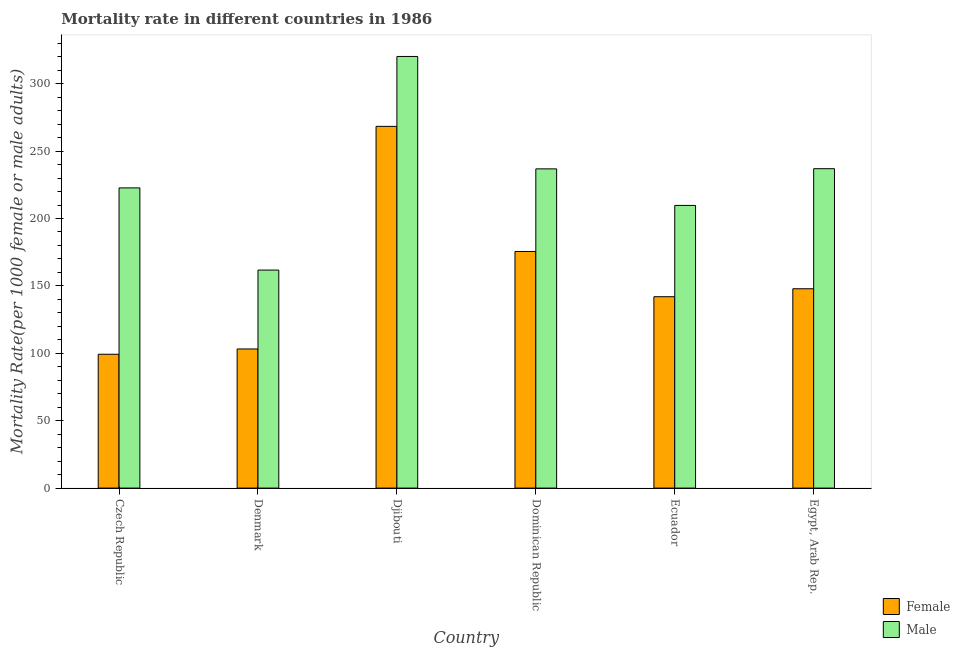How many groups of bars are there?
Your answer should be compact. 6. Are the number of bars on each tick of the X-axis equal?
Your answer should be compact. Yes. How many bars are there on the 6th tick from the left?
Give a very brief answer. 2. What is the label of the 6th group of bars from the left?
Give a very brief answer. Egypt, Arab Rep. In how many cases, is the number of bars for a given country not equal to the number of legend labels?
Offer a very short reply. 0. What is the female mortality rate in Egypt, Arab Rep.?
Keep it short and to the point. 147.88. Across all countries, what is the maximum female mortality rate?
Your response must be concise. 268.34. Across all countries, what is the minimum female mortality rate?
Your response must be concise. 99.28. In which country was the female mortality rate maximum?
Provide a short and direct response. Djibouti. In which country was the male mortality rate minimum?
Provide a short and direct response. Denmark. What is the total male mortality rate in the graph?
Your response must be concise. 1388.06. What is the difference between the male mortality rate in Dominican Republic and that in Ecuador?
Offer a terse response. 27.11. What is the difference between the male mortality rate in Ecuador and the female mortality rate in Czech Republic?
Ensure brevity in your answer.  110.41. What is the average male mortality rate per country?
Your response must be concise. 231.34. What is the difference between the male mortality rate and female mortality rate in Czech Republic?
Give a very brief answer. 123.42. What is the ratio of the female mortality rate in Czech Republic to that in Ecuador?
Give a very brief answer. 0.7. Is the female mortality rate in Denmark less than that in Egypt, Arab Rep.?
Provide a short and direct response. Yes. What is the difference between the highest and the second highest female mortality rate?
Offer a very short reply. 92.81. What is the difference between the highest and the lowest female mortality rate?
Ensure brevity in your answer.  169.06. What does the 1st bar from the left in Czech Republic represents?
Provide a succinct answer. Female. What does the 1st bar from the right in Denmark represents?
Make the answer very short. Male. Are all the bars in the graph horizontal?
Make the answer very short. No. How many countries are there in the graph?
Ensure brevity in your answer.  6. What is the difference between two consecutive major ticks on the Y-axis?
Your response must be concise. 50. Does the graph contain any zero values?
Provide a succinct answer. No. Does the graph contain grids?
Your response must be concise. No. Where does the legend appear in the graph?
Your response must be concise. Bottom right. How are the legend labels stacked?
Your answer should be compact. Vertical. What is the title of the graph?
Offer a very short reply. Mortality rate in different countries in 1986. What is the label or title of the X-axis?
Provide a short and direct response. Country. What is the label or title of the Y-axis?
Offer a terse response. Mortality Rate(per 1000 female or male adults). What is the Mortality Rate(per 1000 female or male adults) in Female in Czech Republic?
Offer a very short reply. 99.28. What is the Mortality Rate(per 1000 female or male adults) of Male in Czech Republic?
Offer a very short reply. 222.7. What is the Mortality Rate(per 1000 female or male adults) of Female in Denmark?
Your answer should be compact. 103.21. What is the Mortality Rate(per 1000 female or male adults) of Male in Denmark?
Your answer should be compact. 161.73. What is the Mortality Rate(per 1000 female or male adults) of Female in Djibouti?
Ensure brevity in your answer.  268.34. What is the Mortality Rate(per 1000 female or male adults) in Male in Djibouti?
Your answer should be compact. 320.2. What is the Mortality Rate(per 1000 female or male adults) of Female in Dominican Republic?
Provide a short and direct response. 175.53. What is the Mortality Rate(per 1000 female or male adults) in Male in Dominican Republic?
Make the answer very short. 236.81. What is the Mortality Rate(per 1000 female or male adults) of Female in Ecuador?
Provide a short and direct response. 141.97. What is the Mortality Rate(per 1000 female or male adults) in Male in Ecuador?
Your answer should be compact. 209.69. What is the Mortality Rate(per 1000 female or male adults) of Female in Egypt, Arab Rep.?
Make the answer very short. 147.88. What is the Mortality Rate(per 1000 female or male adults) in Male in Egypt, Arab Rep.?
Keep it short and to the point. 236.94. Across all countries, what is the maximum Mortality Rate(per 1000 female or male adults) of Female?
Your answer should be very brief. 268.34. Across all countries, what is the maximum Mortality Rate(per 1000 female or male adults) in Male?
Your answer should be very brief. 320.2. Across all countries, what is the minimum Mortality Rate(per 1000 female or male adults) of Female?
Ensure brevity in your answer.  99.28. Across all countries, what is the minimum Mortality Rate(per 1000 female or male adults) of Male?
Make the answer very short. 161.73. What is the total Mortality Rate(per 1000 female or male adults) of Female in the graph?
Give a very brief answer. 936.2. What is the total Mortality Rate(per 1000 female or male adults) of Male in the graph?
Your answer should be compact. 1388.06. What is the difference between the Mortality Rate(per 1000 female or male adults) in Female in Czech Republic and that in Denmark?
Provide a succinct answer. -3.93. What is the difference between the Mortality Rate(per 1000 female or male adults) of Male in Czech Republic and that in Denmark?
Offer a very short reply. 60.97. What is the difference between the Mortality Rate(per 1000 female or male adults) of Female in Czech Republic and that in Djibouti?
Give a very brief answer. -169.06. What is the difference between the Mortality Rate(per 1000 female or male adults) of Male in Czech Republic and that in Djibouti?
Ensure brevity in your answer.  -97.5. What is the difference between the Mortality Rate(per 1000 female or male adults) of Female in Czech Republic and that in Dominican Republic?
Provide a short and direct response. -76.25. What is the difference between the Mortality Rate(per 1000 female or male adults) of Male in Czech Republic and that in Dominican Republic?
Your answer should be compact. -14.11. What is the difference between the Mortality Rate(per 1000 female or male adults) in Female in Czech Republic and that in Ecuador?
Provide a succinct answer. -42.69. What is the difference between the Mortality Rate(per 1000 female or male adults) of Male in Czech Republic and that in Ecuador?
Offer a very short reply. 13.01. What is the difference between the Mortality Rate(per 1000 female or male adults) in Female in Czech Republic and that in Egypt, Arab Rep.?
Your response must be concise. -48.59. What is the difference between the Mortality Rate(per 1000 female or male adults) of Male in Czech Republic and that in Egypt, Arab Rep.?
Keep it short and to the point. -14.24. What is the difference between the Mortality Rate(per 1000 female or male adults) in Female in Denmark and that in Djibouti?
Give a very brief answer. -165.13. What is the difference between the Mortality Rate(per 1000 female or male adults) in Male in Denmark and that in Djibouti?
Provide a short and direct response. -158.47. What is the difference between the Mortality Rate(per 1000 female or male adults) in Female in Denmark and that in Dominican Republic?
Give a very brief answer. -72.32. What is the difference between the Mortality Rate(per 1000 female or male adults) in Male in Denmark and that in Dominican Republic?
Your response must be concise. -75.08. What is the difference between the Mortality Rate(per 1000 female or male adults) of Female in Denmark and that in Ecuador?
Your response must be concise. -38.76. What is the difference between the Mortality Rate(per 1000 female or male adults) in Male in Denmark and that in Ecuador?
Your answer should be compact. -47.96. What is the difference between the Mortality Rate(per 1000 female or male adults) of Female in Denmark and that in Egypt, Arab Rep.?
Make the answer very short. -44.67. What is the difference between the Mortality Rate(per 1000 female or male adults) of Male in Denmark and that in Egypt, Arab Rep.?
Make the answer very short. -75.21. What is the difference between the Mortality Rate(per 1000 female or male adults) in Female in Djibouti and that in Dominican Republic?
Ensure brevity in your answer.  92.81. What is the difference between the Mortality Rate(per 1000 female or male adults) in Male in Djibouti and that in Dominican Republic?
Offer a terse response. 83.39. What is the difference between the Mortality Rate(per 1000 female or male adults) of Female in Djibouti and that in Ecuador?
Ensure brevity in your answer.  126.37. What is the difference between the Mortality Rate(per 1000 female or male adults) of Male in Djibouti and that in Ecuador?
Your response must be concise. 110.51. What is the difference between the Mortality Rate(per 1000 female or male adults) in Female in Djibouti and that in Egypt, Arab Rep.?
Provide a succinct answer. 120.46. What is the difference between the Mortality Rate(per 1000 female or male adults) of Male in Djibouti and that in Egypt, Arab Rep.?
Provide a succinct answer. 83.27. What is the difference between the Mortality Rate(per 1000 female or male adults) of Female in Dominican Republic and that in Ecuador?
Give a very brief answer. 33.56. What is the difference between the Mortality Rate(per 1000 female or male adults) of Male in Dominican Republic and that in Ecuador?
Ensure brevity in your answer.  27.11. What is the difference between the Mortality Rate(per 1000 female or male adults) of Female in Dominican Republic and that in Egypt, Arab Rep.?
Make the answer very short. 27.66. What is the difference between the Mortality Rate(per 1000 female or male adults) of Male in Dominican Republic and that in Egypt, Arab Rep.?
Offer a terse response. -0.13. What is the difference between the Mortality Rate(per 1000 female or male adults) in Female in Ecuador and that in Egypt, Arab Rep.?
Provide a succinct answer. -5.91. What is the difference between the Mortality Rate(per 1000 female or male adults) in Male in Ecuador and that in Egypt, Arab Rep.?
Offer a very short reply. -27.24. What is the difference between the Mortality Rate(per 1000 female or male adults) of Female in Czech Republic and the Mortality Rate(per 1000 female or male adults) of Male in Denmark?
Give a very brief answer. -62.45. What is the difference between the Mortality Rate(per 1000 female or male adults) of Female in Czech Republic and the Mortality Rate(per 1000 female or male adults) of Male in Djibouti?
Your response must be concise. -220.92. What is the difference between the Mortality Rate(per 1000 female or male adults) in Female in Czech Republic and the Mortality Rate(per 1000 female or male adults) in Male in Dominican Republic?
Your answer should be very brief. -137.53. What is the difference between the Mortality Rate(per 1000 female or male adults) in Female in Czech Republic and the Mortality Rate(per 1000 female or male adults) in Male in Ecuador?
Offer a terse response. -110.41. What is the difference between the Mortality Rate(per 1000 female or male adults) in Female in Czech Republic and the Mortality Rate(per 1000 female or male adults) in Male in Egypt, Arab Rep.?
Give a very brief answer. -137.66. What is the difference between the Mortality Rate(per 1000 female or male adults) in Female in Denmark and the Mortality Rate(per 1000 female or male adults) in Male in Djibouti?
Offer a terse response. -216.99. What is the difference between the Mortality Rate(per 1000 female or male adults) in Female in Denmark and the Mortality Rate(per 1000 female or male adults) in Male in Dominican Republic?
Provide a short and direct response. -133.6. What is the difference between the Mortality Rate(per 1000 female or male adults) in Female in Denmark and the Mortality Rate(per 1000 female or male adults) in Male in Ecuador?
Offer a terse response. -106.48. What is the difference between the Mortality Rate(per 1000 female or male adults) of Female in Denmark and the Mortality Rate(per 1000 female or male adults) of Male in Egypt, Arab Rep.?
Your answer should be very brief. -133.73. What is the difference between the Mortality Rate(per 1000 female or male adults) in Female in Djibouti and the Mortality Rate(per 1000 female or male adults) in Male in Dominican Republic?
Keep it short and to the point. 31.53. What is the difference between the Mortality Rate(per 1000 female or male adults) in Female in Djibouti and the Mortality Rate(per 1000 female or male adults) in Male in Ecuador?
Give a very brief answer. 58.65. What is the difference between the Mortality Rate(per 1000 female or male adults) in Female in Djibouti and the Mortality Rate(per 1000 female or male adults) in Male in Egypt, Arab Rep.?
Make the answer very short. 31.4. What is the difference between the Mortality Rate(per 1000 female or male adults) in Female in Dominican Republic and the Mortality Rate(per 1000 female or male adults) in Male in Ecuador?
Your answer should be compact. -34.16. What is the difference between the Mortality Rate(per 1000 female or male adults) in Female in Dominican Republic and the Mortality Rate(per 1000 female or male adults) in Male in Egypt, Arab Rep.?
Make the answer very short. -61.41. What is the difference between the Mortality Rate(per 1000 female or male adults) in Female in Ecuador and the Mortality Rate(per 1000 female or male adults) in Male in Egypt, Arab Rep.?
Offer a terse response. -94.97. What is the average Mortality Rate(per 1000 female or male adults) of Female per country?
Your answer should be compact. 156.03. What is the average Mortality Rate(per 1000 female or male adults) in Male per country?
Make the answer very short. 231.34. What is the difference between the Mortality Rate(per 1000 female or male adults) in Female and Mortality Rate(per 1000 female or male adults) in Male in Czech Republic?
Your response must be concise. -123.42. What is the difference between the Mortality Rate(per 1000 female or male adults) in Female and Mortality Rate(per 1000 female or male adults) in Male in Denmark?
Make the answer very short. -58.52. What is the difference between the Mortality Rate(per 1000 female or male adults) in Female and Mortality Rate(per 1000 female or male adults) in Male in Djibouti?
Give a very brief answer. -51.86. What is the difference between the Mortality Rate(per 1000 female or male adults) in Female and Mortality Rate(per 1000 female or male adults) in Male in Dominican Republic?
Make the answer very short. -61.28. What is the difference between the Mortality Rate(per 1000 female or male adults) of Female and Mortality Rate(per 1000 female or male adults) of Male in Ecuador?
Offer a very short reply. -67.72. What is the difference between the Mortality Rate(per 1000 female or male adults) in Female and Mortality Rate(per 1000 female or male adults) in Male in Egypt, Arab Rep.?
Keep it short and to the point. -89.06. What is the ratio of the Mortality Rate(per 1000 female or male adults) in Female in Czech Republic to that in Denmark?
Your answer should be compact. 0.96. What is the ratio of the Mortality Rate(per 1000 female or male adults) in Male in Czech Republic to that in Denmark?
Your answer should be compact. 1.38. What is the ratio of the Mortality Rate(per 1000 female or male adults) in Female in Czech Republic to that in Djibouti?
Offer a terse response. 0.37. What is the ratio of the Mortality Rate(per 1000 female or male adults) of Male in Czech Republic to that in Djibouti?
Your answer should be compact. 0.7. What is the ratio of the Mortality Rate(per 1000 female or male adults) of Female in Czech Republic to that in Dominican Republic?
Ensure brevity in your answer.  0.57. What is the ratio of the Mortality Rate(per 1000 female or male adults) in Male in Czech Republic to that in Dominican Republic?
Your answer should be compact. 0.94. What is the ratio of the Mortality Rate(per 1000 female or male adults) in Female in Czech Republic to that in Ecuador?
Make the answer very short. 0.7. What is the ratio of the Mortality Rate(per 1000 female or male adults) in Male in Czech Republic to that in Ecuador?
Provide a short and direct response. 1.06. What is the ratio of the Mortality Rate(per 1000 female or male adults) of Female in Czech Republic to that in Egypt, Arab Rep.?
Your response must be concise. 0.67. What is the ratio of the Mortality Rate(per 1000 female or male adults) in Male in Czech Republic to that in Egypt, Arab Rep.?
Ensure brevity in your answer.  0.94. What is the ratio of the Mortality Rate(per 1000 female or male adults) in Female in Denmark to that in Djibouti?
Make the answer very short. 0.38. What is the ratio of the Mortality Rate(per 1000 female or male adults) of Male in Denmark to that in Djibouti?
Ensure brevity in your answer.  0.51. What is the ratio of the Mortality Rate(per 1000 female or male adults) of Female in Denmark to that in Dominican Republic?
Ensure brevity in your answer.  0.59. What is the ratio of the Mortality Rate(per 1000 female or male adults) of Male in Denmark to that in Dominican Republic?
Offer a terse response. 0.68. What is the ratio of the Mortality Rate(per 1000 female or male adults) of Female in Denmark to that in Ecuador?
Keep it short and to the point. 0.73. What is the ratio of the Mortality Rate(per 1000 female or male adults) of Male in Denmark to that in Ecuador?
Keep it short and to the point. 0.77. What is the ratio of the Mortality Rate(per 1000 female or male adults) in Female in Denmark to that in Egypt, Arab Rep.?
Give a very brief answer. 0.7. What is the ratio of the Mortality Rate(per 1000 female or male adults) in Male in Denmark to that in Egypt, Arab Rep.?
Keep it short and to the point. 0.68. What is the ratio of the Mortality Rate(per 1000 female or male adults) in Female in Djibouti to that in Dominican Republic?
Provide a succinct answer. 1.53. What is the ratio of the Mortality Rate(per 1000 female or male adults) in Male in Djibouti to that in Dominican Republic?
Keep it short and to the point. 1.35. What is the ratio of the Mortality Rate(per 1000 female or male adults) of Female in Djibouti to that in Ecuador?
Provide a short and direct response. 1.89. What is the ratio of the Mortality Rate(per 1000 female or male adults) of Male in Djibouti to that in Ecuador?
Ensure brevity in your answer.  1.53. What is the ratio of the Mortality Rate(per 1000 female or male adults) in Female in Djibouti to that in Egypt, Arab Rep.?
Your answer should be compact. 1.81. What is the ratio of the Mortality Rate(per 1000 female or male adults) in Male in Djibouti to that in Egypt, Arab Rep.?
Ensure brevity in your answer.  1.35. What is the ratio of the Mortality Rate(per 1000 female or male adults) of Female in Dominican Republic to that in Ecuador?
Make the answer very short. 1.24. What is the ratio of the Mortality Rate(per 1000 female or male adults) of Male in Dominican Republic to that in Ecuador?
Your answer should be compact. 1.13. What is the ratio of the Mortality Rate(per 1000 female or male adults) of Female in Dominican Republic to that in Egypt, Arab Rep.?
Your response must be concise. 1.19. What is the ratio of the Mortality Rate(per 1000 female or male adults) in Male in Dominican Republic to that in Egypt, Arab Rep.?
Your response must be concise. 1. What is the ratio of the Mortality Rate(per 1000 female or male adults) of Female in Ecuador to that in Egypt, Arab Rep.?
Give a very brief answer. 0.96. What is the ratio of the Mortality Rate(per 1000 female or male adults) in Male in Ecuador to that in Egypt, Arab Rep.?
Make the answer very short. 0.89. What is the difference between the highest and the second highest Mortality Rate(per 1000 female or male adults) in Female?
Offer a very short reply. 92.81. What is the difference between the highest and the second highest Mortality Rate(per 1000 female or male adults) of Male?
Make the answer very short. 83.27. What is the difference between the highest and the lowest Mortality Rate(per 1000 female or male adults) of Female?
Your response must be concise. 169.06. What is the difference between the highest and the lowest Mortality Rate(per 1000 female or male adults) in Male?
Keep it short and to the point. 158.47. 